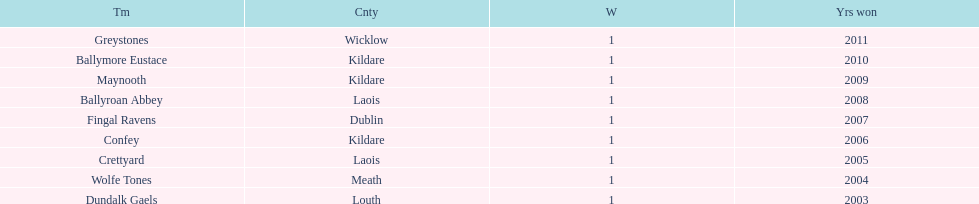Can you provide the win tally for each team? 1. 